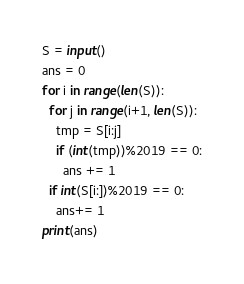Convert code to text. <code><loc_0><loc_0><loc_500><loc_500><_Python_>S = input()
ans = 0
for i in range(len(S)):
  for j in range(i+1, len(S)):
    tmp = S[i:j]
    if (int(tmp))%2019 == 0:
      ans += 1
  if int(S[i:])%2019 == 0:
    ans+= 1
print(ans)</code> 